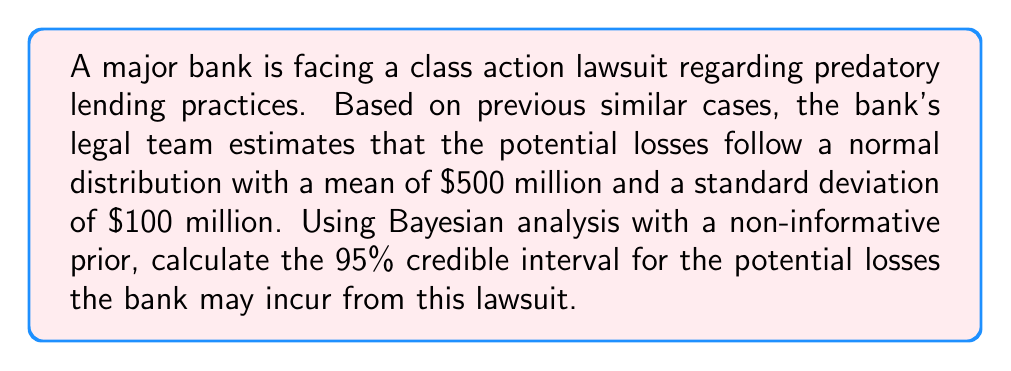Can you answer this question? To calculate the 95% credible interval using Bayesian analysis with a non-informative prior and normally distributed data, we can follow these steps:

1. Given:
   - Mean ($\mu$) = $500 million
   - Standard deviation ($\sigma$) = $100 million
   - Desired credible interval = 95%

2. For a normal distribution with a non-informative prior, the posterior distribution is also normal. The 95% credible interval is symmetric around the mean and extends 1.96 standard deviations in each direction.

3. Calculate the margin of error:
   $\text{Margin of Error} = 1.96 \times \sigma = 1.96 \times 100 = 196$ million

4. Calculate the lower bound of the credible interval:
   $\text{Lower Bound} = \mu - \text{Margin of Error} = 500 - 196 = 304$ million

5. Calculate the upper bound of the credible interval:
   $\text{Upper Bound} = \mu + \text{Margin of Error} = 500 + 196 = 696$ million

Therefore, the 95% credible interval for the potential losses is [$304 million, $696 million].

This means that, based on the given information and Bayesian analysis, we can be 95% confident that the true value of potential losses falls within this range.
Answer: The 95% credible interval for potential losses is [$304 million, $696 million]. 